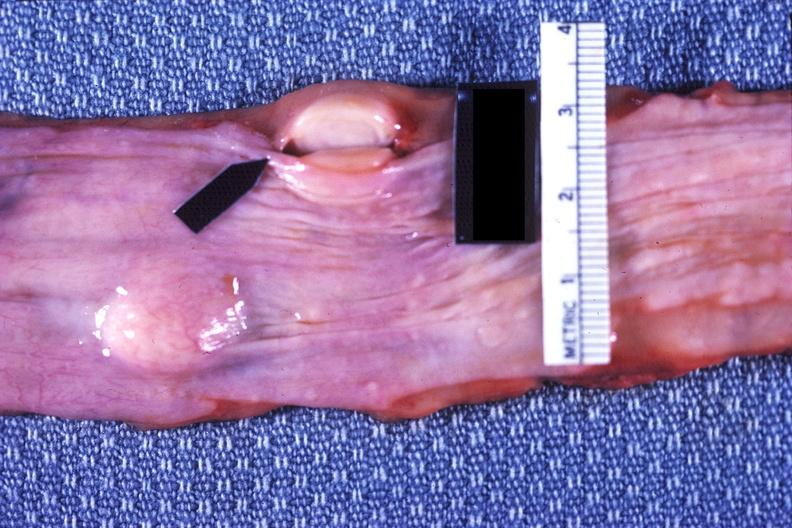what is present?
Answer the question using a single word or phrase. Gastrointestinal 